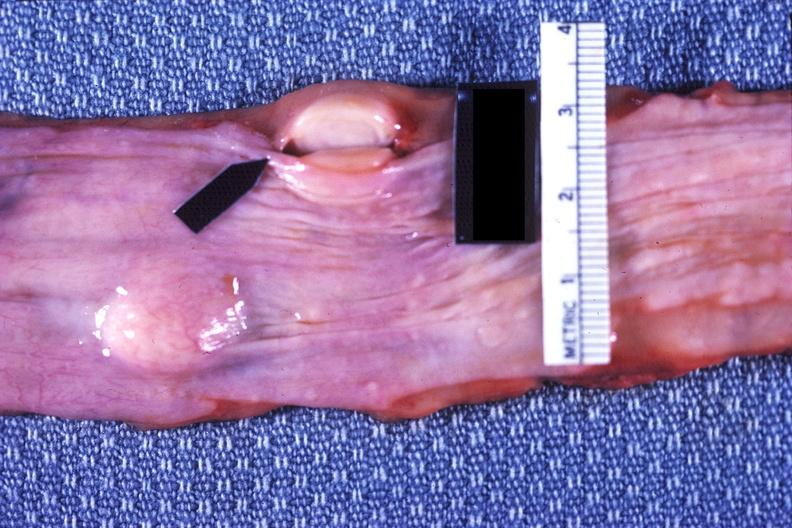what is present?
Answer the question using a single word or phrase. Gastrointestinal 